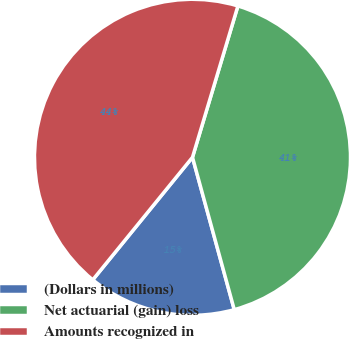<chart> <loc_0><loc_0><loc_500><loc_500><pie_chart><fcel>(Dollars in millions)<fcel>Net actuarial (gain) loss<fcel>Amounts recognized in<nl><fcel>15.13%<fcel>41.1%<fcel>43.77%<nl></chart> 